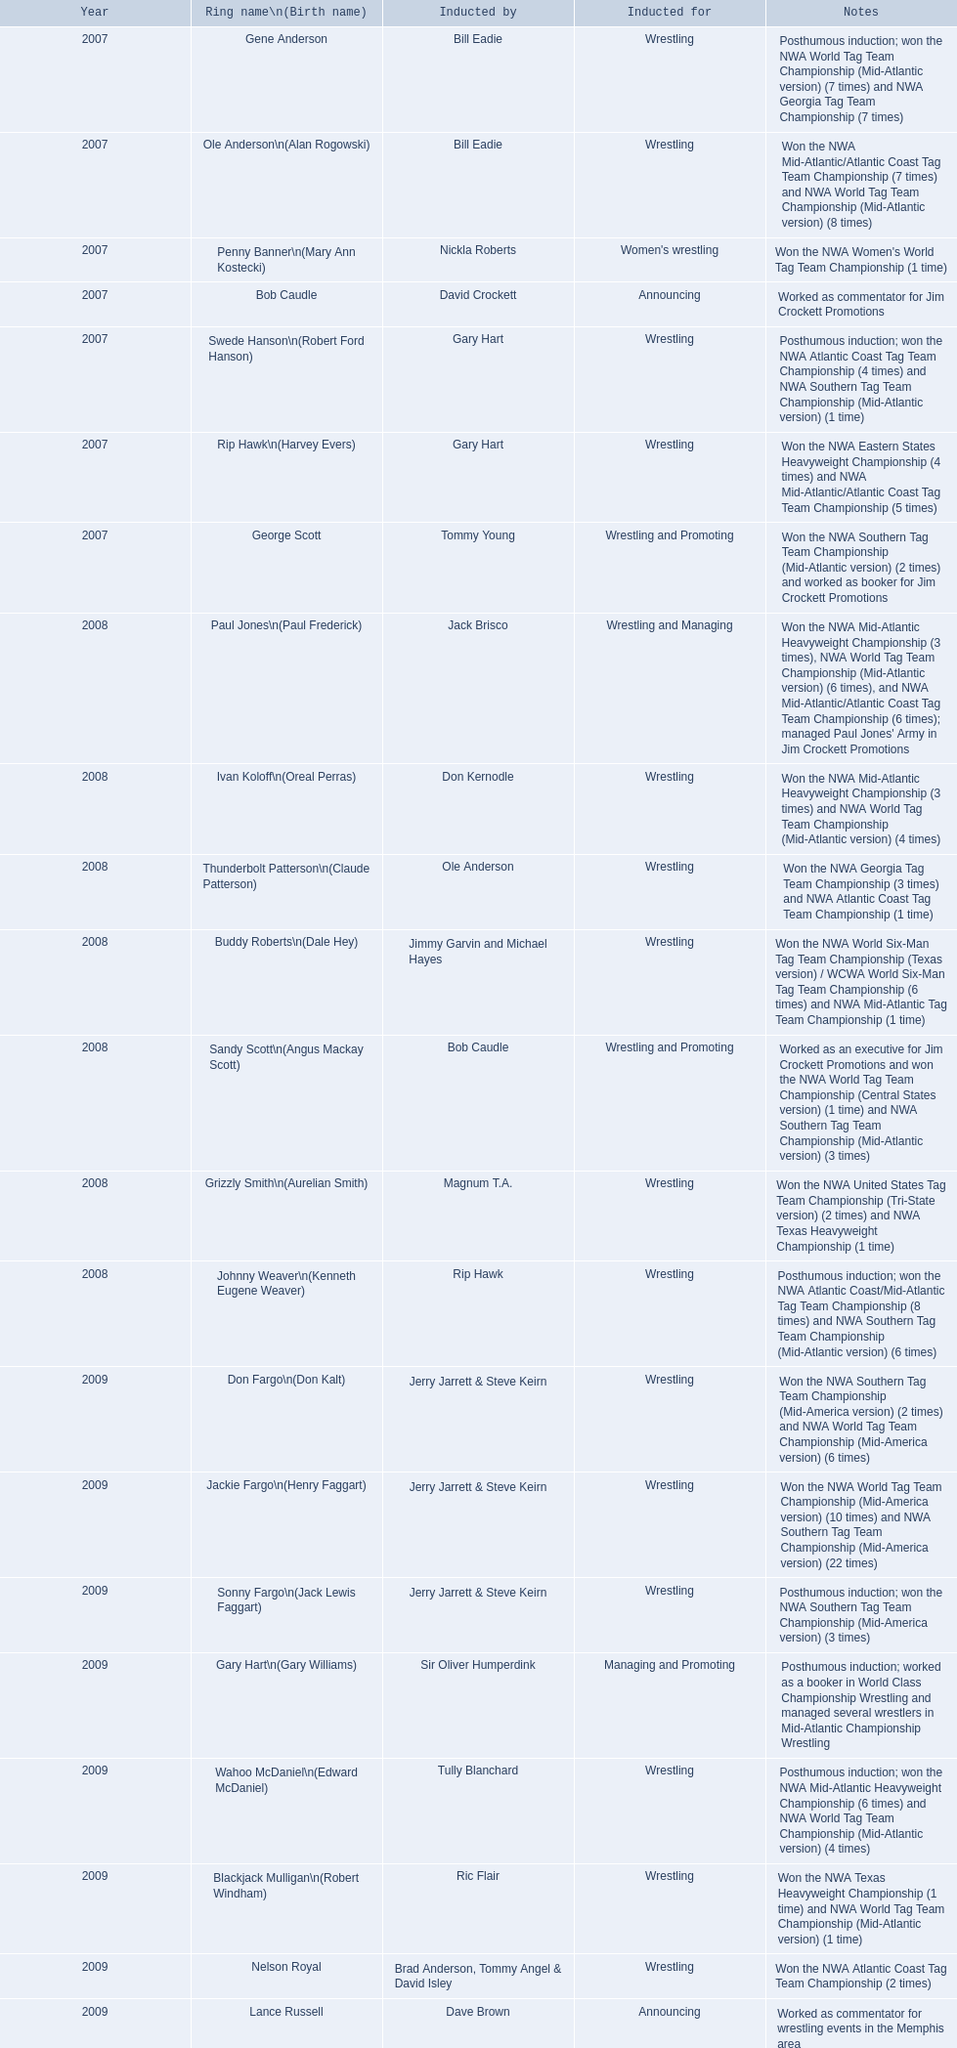What year was the induction held? 2007. Which inductee was not alive? Gene Anderson. 